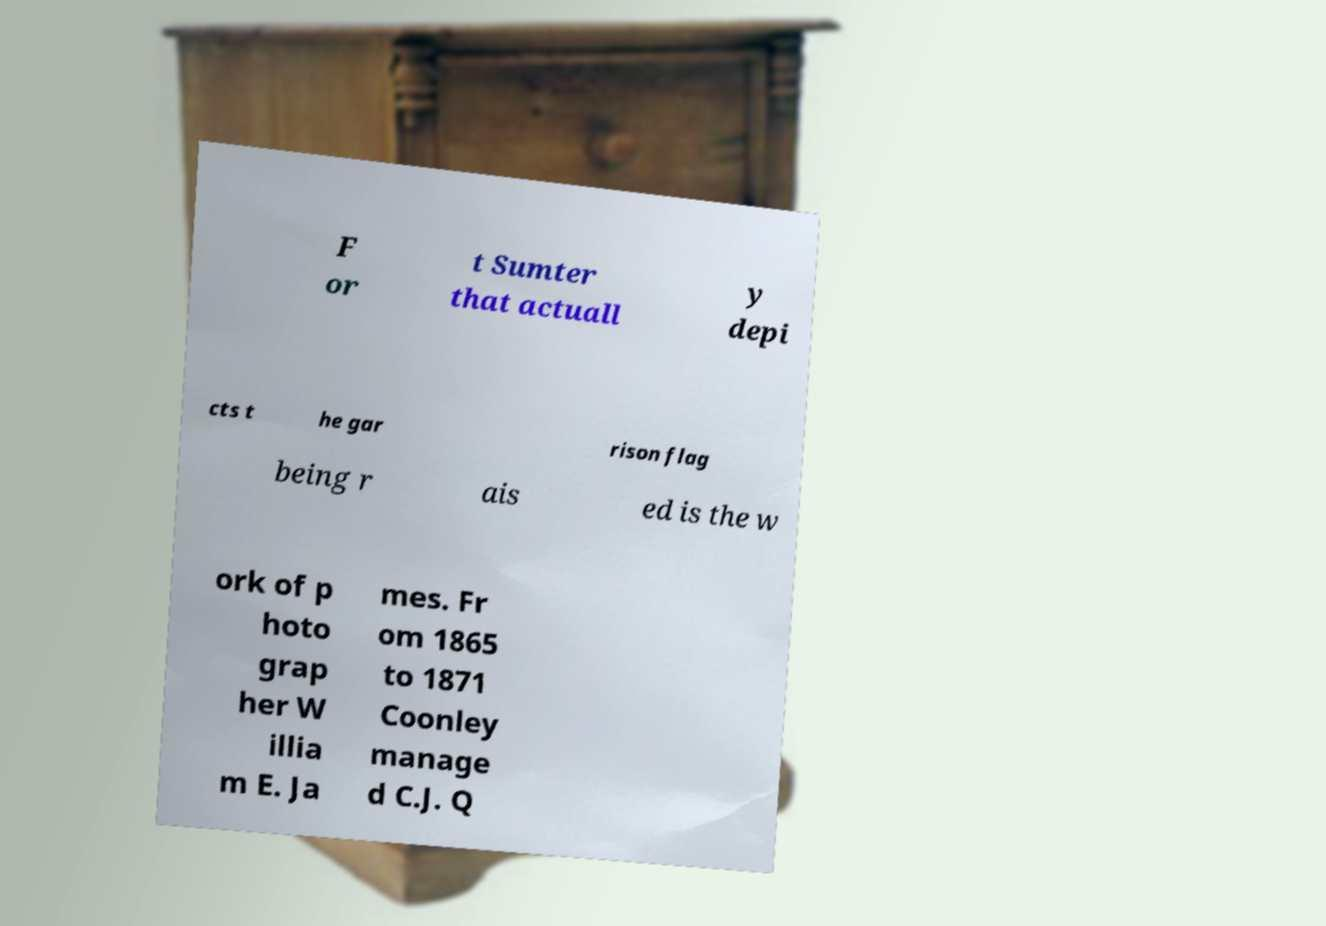For documentation purposes, I need the text within this image transcribed. Could you provide that? F or t Sumter that actuall y depi cts t he gar rison flag being r ais ed is the w ork of p hoto grap her W illia m E. Ja mes. Fr om 1865 to 1871 Coonley manage d C.J. Q 